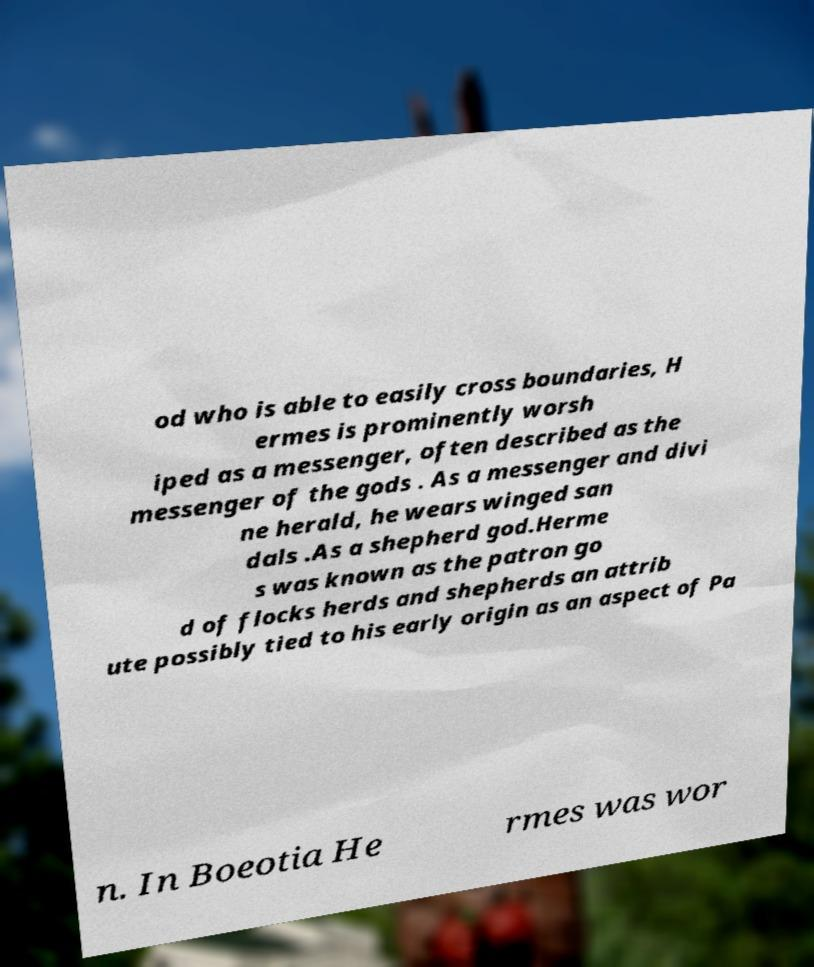Can you accurately transcribe the text from the provided image for me? od who is able to easily cross boundaries, H ermes is prominently worsh iped as a messenger, often described as the messenger of the gods . As a messenger and divi ne herald, he wears winged san dals .As a shepherd god.Herme s was known as the patron go d of flocks herds and shepherds an attrib ute possibly tied to his early origin as an aspect of Pa n. In Boeotia He rmes was wor 